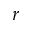<formula> <loc_0><loc_0><loc_500><loc_500>r</formula> 